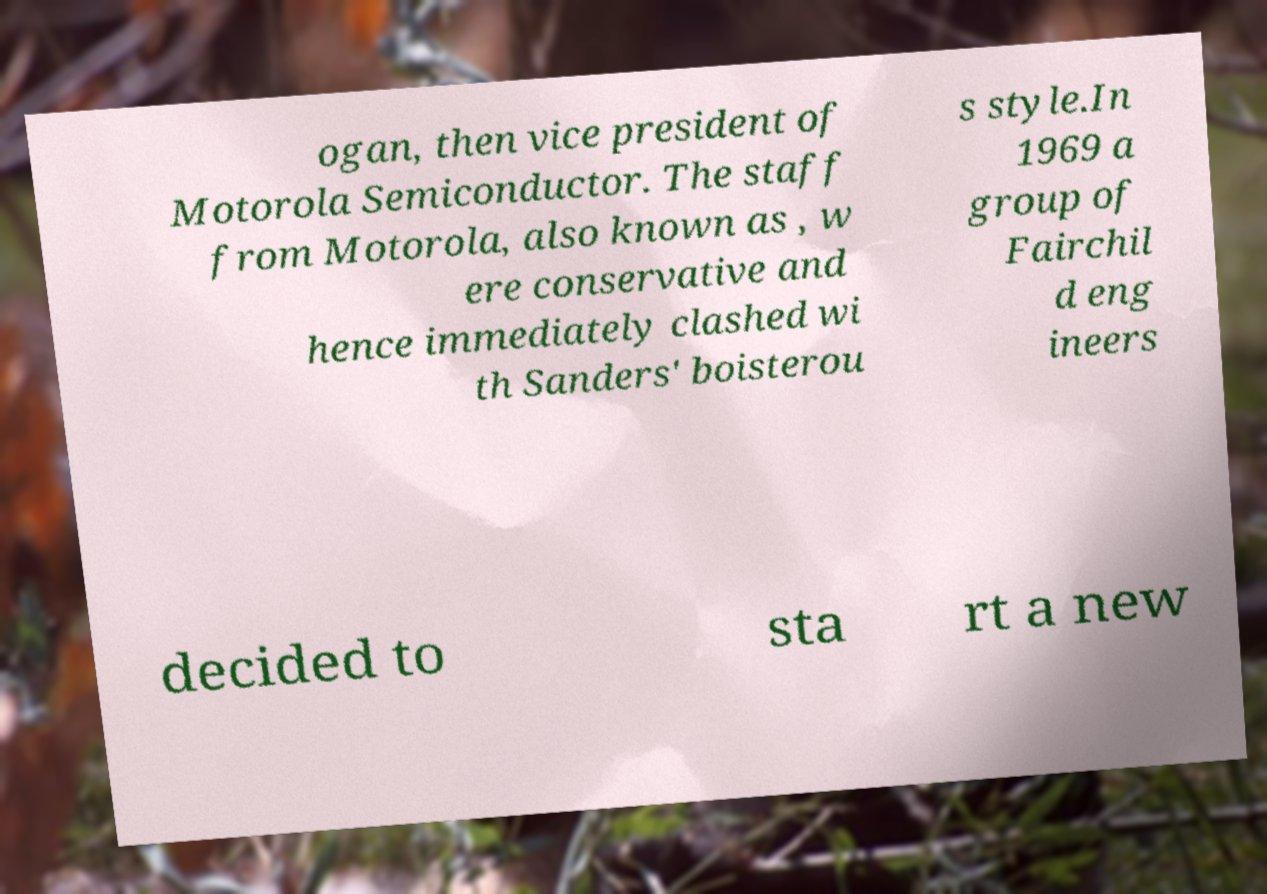Please read and relay the text visible in this image. What does it say? ogan, then vice president of Motorola Semiconductor. The staff from Motorola, also known as , w ere conservative and hence immediately clashed wi th Sanders' boisterou s style.In 1969 a group of Fairchil d eng ineers decided to sta rt a new 